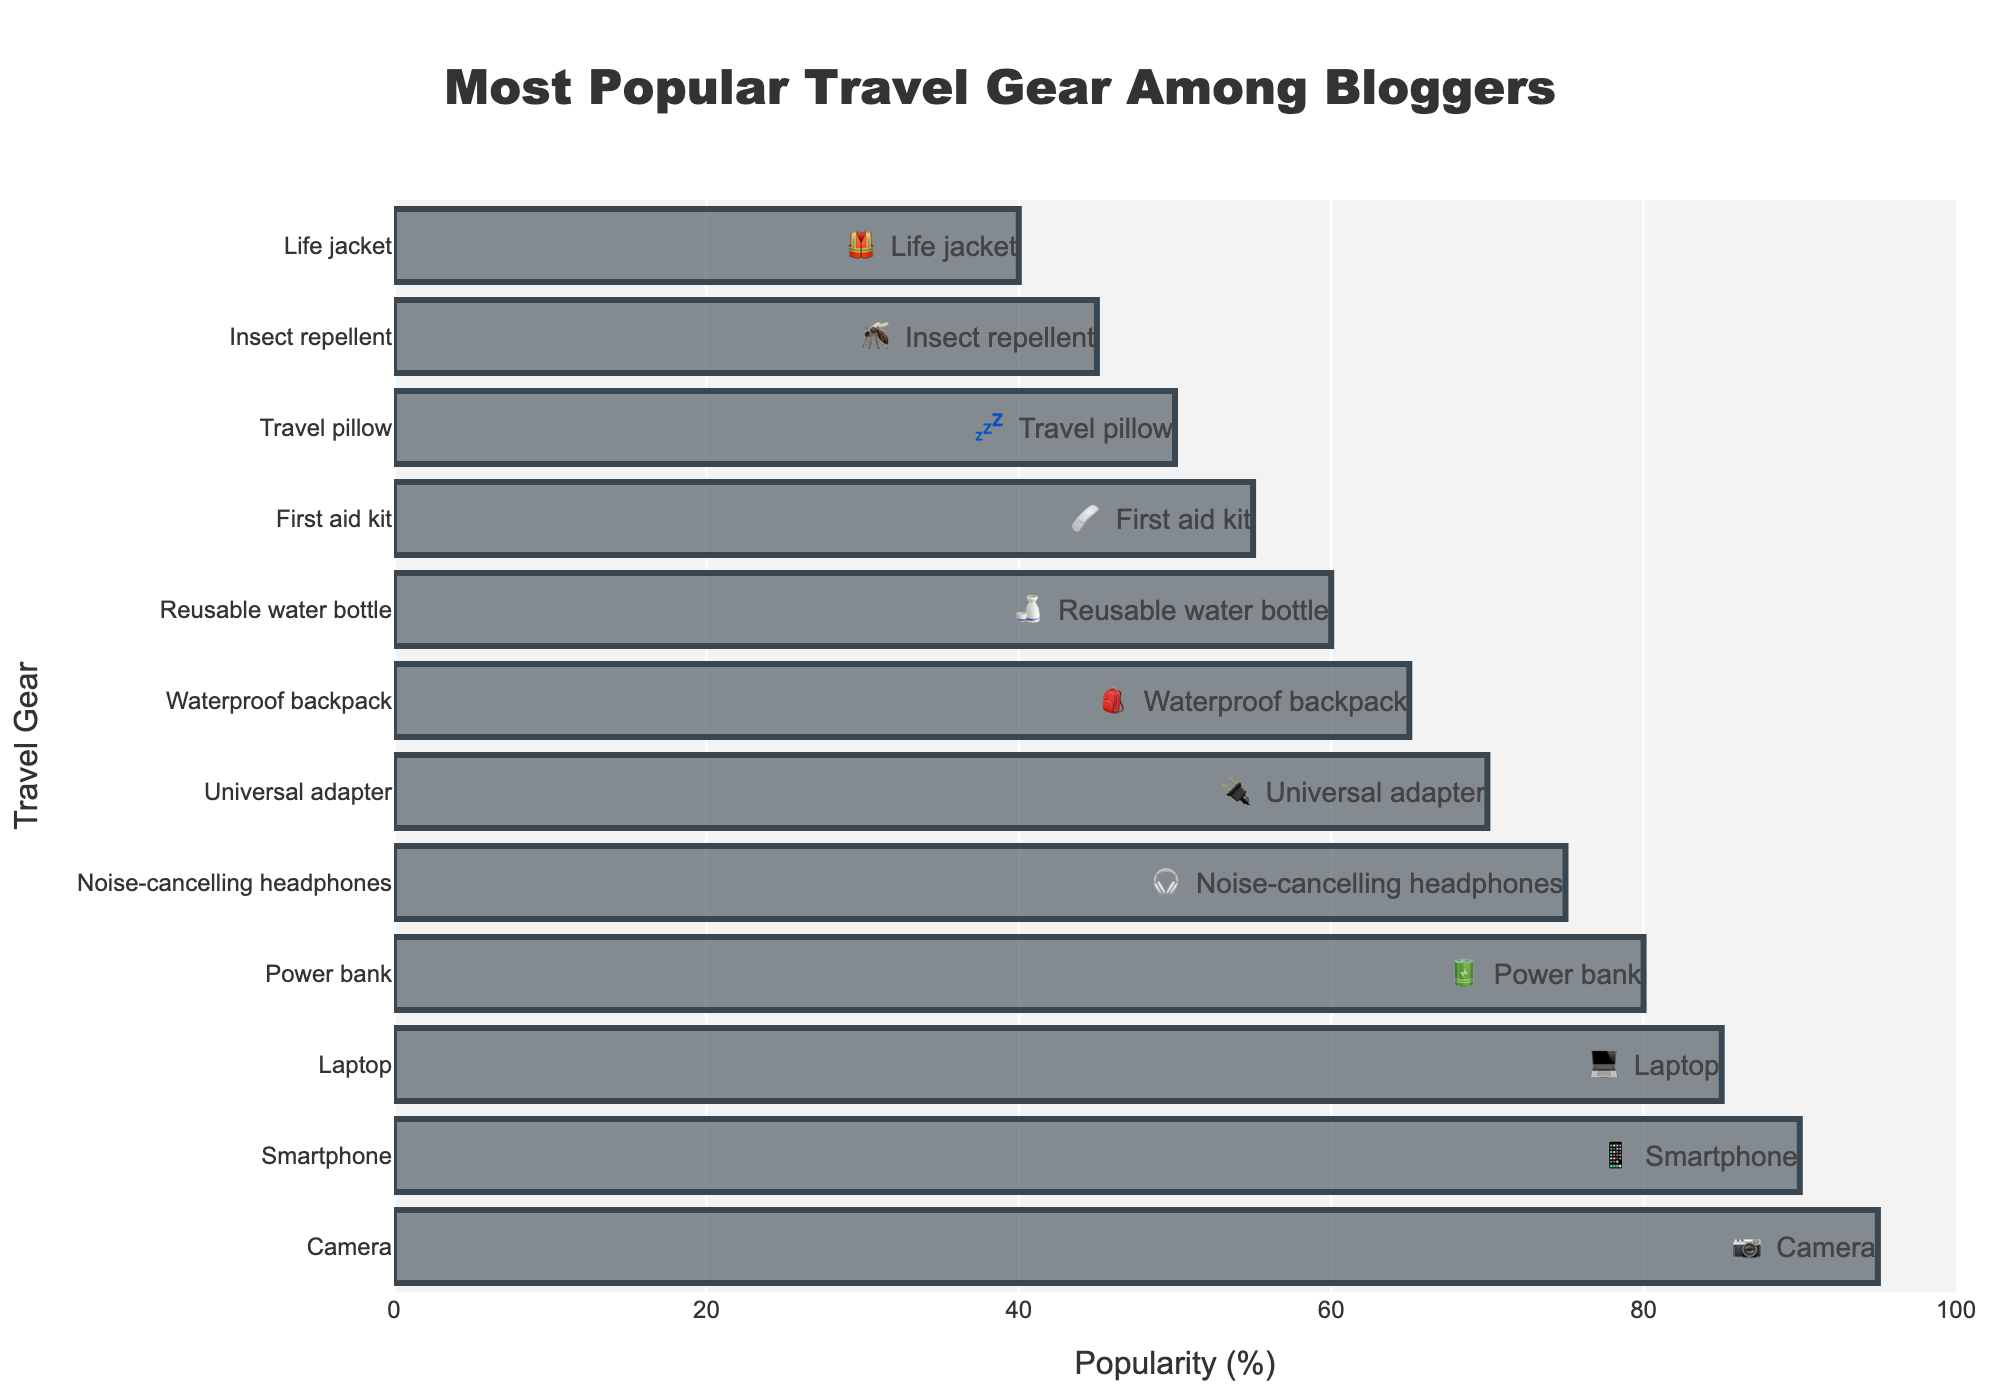which travel gear item is the most popular? The highest bar represents the popularity percentage of the travel gear item. The bar with the highest percentage is labeled Camera.
Answer: Camera How many travel gear items have a popularity score of 75 or above? Count the number of bars with popularity values of 75 or greater. There are five: Camera, Smartphone, Laptop, Power bank, and Noise-cancelling headphones.
Answer: Five Which two travel gear items have the lowest popularity? Identify the two smallest bars. They are Insect repellent and Life jacket, with the lowest percentages.
Answer: Insect repellent, Life jacket What is the difference in popularity between the Camera and the Life jacket? Subtract the popularity value of the Life jacket (40) from the popularity value of the Camera (95). 95 - 40 = 55.
Answer: 55 What is the average popularity of the top 3 travel gear items? Add the popularity values of the top 3 items (95 for Camera, 90 for Smartphone, and 85 for Laptop) and divide by 3. (95 + 90 + 85) / 3 = 90.
Answer: 90 Which item is more popular: Reusable water bottle or Waterproof backpack? Compare the bar heights and percentages of Reusable water bottle (60) and Waterproof backpack (65).
Answer: Waterproof backpack How many travel gear items are represented in the figure? Count all the bars in the figure. There are 12 bars representing 12 items.
Answer: 12 What emoji is used for the Travel pillow? The bar labeled Travel pillow is accompanied by the emoji 💤.
Answer: 💤 By how many percentage points is the Universal adapter less popular than the Noise-cancelling headphones? Subtract the percentage of the Universal adapter (70) from the Noise-cancelling headphones (75). 75 - 70 = 5.
Answer: 5 